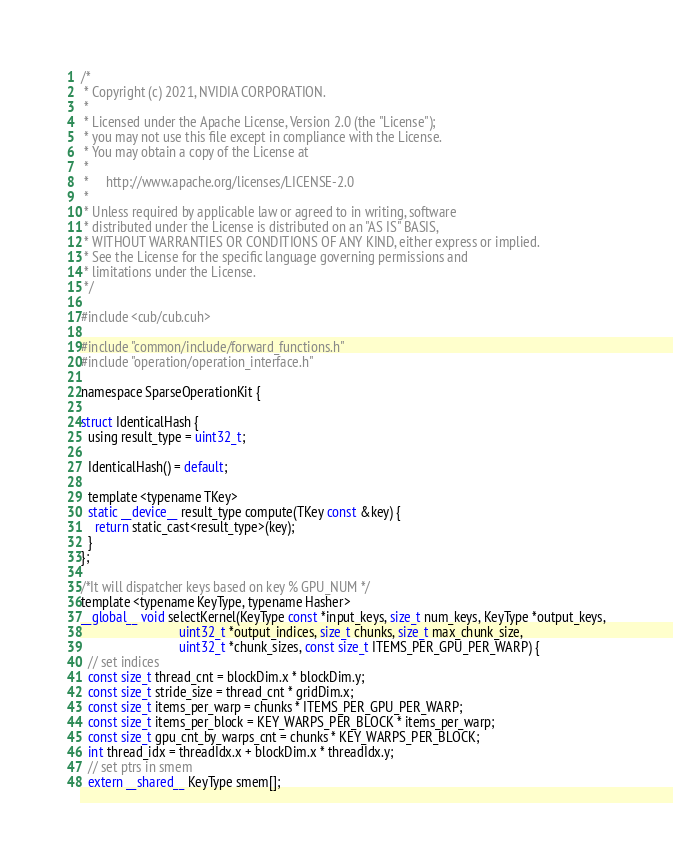Convert code to text. <code><loc_0><loc_0><loc_500><loc_500><_Cuda_>/*
 * Copyright (c) 2021, NVIDIA CORPORATION.
 *
 * Licensed under the Apache License, Version 2.0 (the "License");
 * you may not use this file except in compliance with the License.
 * You may obtain a copy of the License at
 *
 *     http://www.apache.org/licenses/LICENSE-2.0
 *
 * Unless required by applicable law or agreed to in writing, software
 * distributed under the License is distributed on an "AS IS" BASIS,
 * WITHOUT WARRANTIES OR CONDITIONS OF ANY KIND, either express or implied.
 * See the License for the specific language governing permissions and
 * limitations under the License.
 */

#include <cub/cub.cuh>

#include "common/include/forward_functions.h"
#include "operation/operation_interface.h"

namespace SparseOperationKit {

struct IdenticalHash {
  using result_type = uint32_t;

  IdenticalHash() = default;

  template <typename TKey>
  static __device__ result_type compute(TKey const &key) {
    return static_cast<result_type>(key);
  }
};

/*It will dispatcher keys based on key % GPU_NUM */
template <typename KeyType, typename Hasher>
__global__ void selectKernel(KeyType const *input_keys, size_t num_keys, KeyType *output_keys,
                             uint32_t *output_indices, size_t chunks, size_t max_chunk_size,
                             uint32_t *chunk_sizes, const size_t ITEMS_PER_GPU_PER_WARP) {
  // set indices
  const size_t thread_cnt = blockDim.x * blockDim.y;
  const size_t stride_size = thread_cnt * gridDim.x;
  const size_t items_per_warp = chunks * ITEMS_PER_GPU_PER_WARP;
  const size_t items_per_block = KEY_WARPS_PER_BLOCK * items_per_warp;
  const size_t gpu_cnt_by_warps_cnt = chunks * KEY_WARPS_PER_BLOCK;
  int thread_idx = threadIdx.x + blockDim.x * threadIdx.y;
  // set ptrs in smem
  extern __shared__ KeyType smem[];</code> 